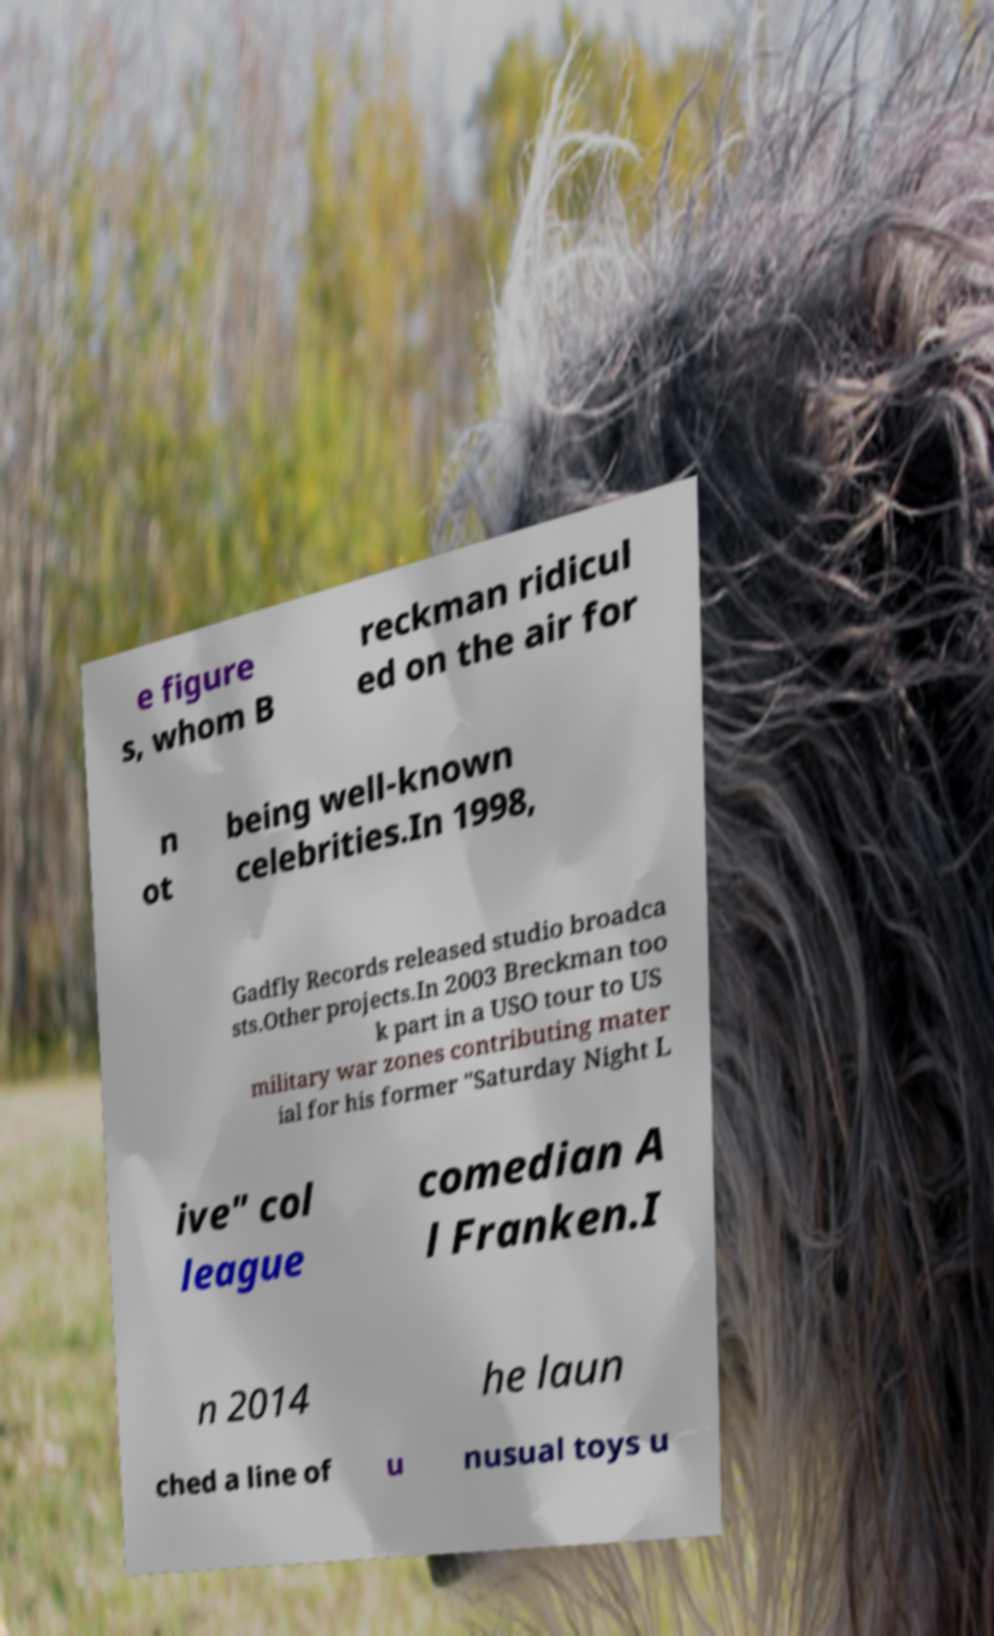Could you extract and type out the text from this image? e figure s, whom B reckman ridicul ed on the air for n ot being well-known celebrities.In 1998, Gadfly Records released studio broadca sts.Other projects.In 2003 Breckman too k part in a USO tour to US military war zones contributing mater ial for his former "Saturday Night L ive" col league comedian A l Franken.I n 2014 he laun ched a line of u nusual toys u 